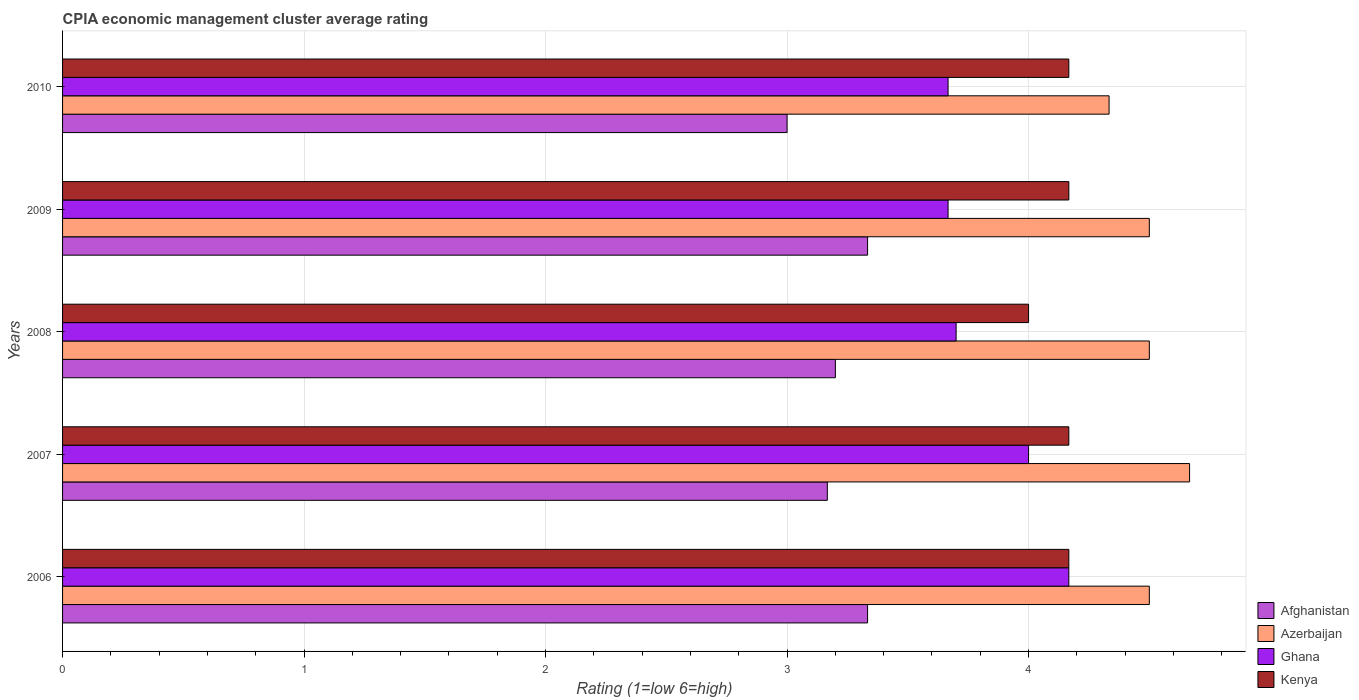Are the number of bars per tick equal to the number of legend labels?
Ensure brevity in your answer.  Yes. What is the label of the 5th group of bars from the top?
Give a very brief answer. 2006. What is the CPIA rating in Ghana in 2006?
Keep it short and to the point. 4.17. Across all years, what is the maximum CPIA rating in Ghana?
Ensure brevity in your answer.  4.17. Across all years, what is the minimum CPIA rating in Ghana?
Make the answer very short. 3.67. What is the total CPIA rating in Kenya in the graph?
Offer a terse response. 20.67. What is the difference between the CPIA rating in Afghanistan in 2008 and that in 2010?
Give a very brief answer. 0.2. What is the difference between the CPIA rating in Kenya in 2006 and the CPIA rating in Afghanistan in 2008?
Offer a terse response. 0.97. What is the average CPIA rating in Kenya per year?
Offer a very short reply. 4.13. In the year 2006, what is the difference between the CPIA rating in Azerbaijan and CPIA rating in Kenya?
Give a very brief answer. 0.33. What is the ratio of the CPIA rating in Kenya in 2006 to that in 2010?
Your answer should be very brief. 1. Is the difference between the CPIA rating in Azerbaijan in 2006 and 2007 greater than the difference between the CPIA rating in Kenya in 2006 and 2007?
Offer a terse response. No. What is the difference between the highest and the second highest CPIA rating in Azerbaijan?
Keep it short and to the point. 0.17. What is the difference between the highest and the lowest CPIA rating in Azerbaijan?
Your answer should be very brief. 0.33. In how many years, is the CPIA rating in Ghana greater than the average CPIA rating in Ghana taken over all years?
Your answer should be very brief. 2. What does the 2nd bar from the bottom in 2006 represents?
Make the answer very short. Azerbaijan. Is it the case that in every year, the sum of the CPIA rating in Ghana and CPIA rating in Afghanistan is greater than the CPIA rating in Azerbaijan?
Offer a terse response. Yes. How many bars are there?
Provide a short and direct response. 20. Where does the legend appear in the graph?
Offer a very short reply. Bottom right. What is the title of the graph?
Ensure brevity in your answer.  CPIA economic management cluster average rating. What is the label or title of the X-axis?
Keep it short and to the point. Rating (1=low 6=high). What is the label or title of the Y-axis?
Make the answer very short. Years. What is the Rating (1=low 6=high) in Afghanistan in 2006?
Offer a very short reply. 3.33. What is the Rating (1=low 6=high) of Azerbaijan in 2006?
Offer a very short reply. 4.5. What is the Rating (1=low 6=high) of Ghana in 2006?
Keep it short and to the point. 4.17. What is the Rating (1=low 6=high) in Kenya in 2006?
Provide a succinct answer. 4.17. What is the Rating (1=low 6=high) in Afghanistan in 2007?
Your answer should be compact. 3.17. What is the Rating (1=low 6=high) of Azerbaijan in 2007?
Provide a succinct answer. 4.67. What is the Rating (1=low 6=high) of Ghana in 2007?
Keep it short and to the point. 4. What is the Rating (1=low 6=high) in Kenya in 2007?
Your answer should be compact. 4.17. What is the Rating (1=low 6=high) of Afghanistan in 2008?
Provide a short and direct response. 3.2. What is the Rating (1=low 6=high) in Azerbaijan in 2008?
Provide a succinct answer. 4.5. What is the Rating (1=low 6=high) of Kenya in 2008?
Ensure brevity in your answer.  4. What is the Rating (1=low 6=high) of Afghanistan in 2009?
Your response must be concise. 3.33. What is the Rating (1=low 6=high) in Ghana in 2009?
Provide a succinct answer. 3.67. What is the Rating (1=low 6=high) of Kenya in 2009?
Provide a succinct answer. 4.17. What is the Rating (1=low 6=high) of Azerbaijan in 2010?
Your response must be concise. 4.33. What is the Rating (1=low 6=high) of Ghana in 2010?
Your answer should be very brief. 3.67. What is the Rating (1=low 6=high) in Kenya in 2010?
Your answer should be compact. 4.17. Across all years, what is the maximum Rating (1=low 6=high) of Afghanistan?
Provide a succinct answer. 3.33. Across all years, what is the maximum Rating (1=low 6=high) of Azerbaijan?
Make the answer very short. 4.67. Across all years, what is the maximum Rating (1=low 6=high) of Ghana?
Make the answer very short. 4.17. Across all years, what is the maximum Rating (1=low 6=high) in Kenya?
Provide a short and direct response. 4.17. Across all years, what is the minimum Rating (1=low 6=high) of Azerbaijan?
Your answer should be very brief. 4.33. Across all years, what is the minimum Rating (1=low 6=high) in Ghana?
Offer a terse response. 3.67. Across all years, what is the minimum Rating (1=low 6=high) in Kenya?
Provide a short and direct response. 4. What is the total Rating (1=low 6=high) of Afghanistan in the graph?
Ensure brevity in your answer.  16.03. What is the total Rating (1=low 6=high) of Azerbaijan in the graph?
Make the answer very short. 22.5. What is the total Rating (1=low 6=high) in Ghana in the graph?
Provide a short and direct response. 19.2. What is the total Rating (1=low 6=high) of Kenya in the graph?
Make the answer very short. 20.67. What is the difference between the Rating (1=low 6=high) of Afghanistan in 2006 and that in 2007?
Provide a succinct answer. 0.17. What is the difference between the Rating (1=low 6=high) of Azerbaijan in 2006 and that in 2007?
Provide a succinct answer. -0.17. What is the difference between the Rating (1=low 6=high) of Kenya in 2006 and that in 2007?
Your response must be concise. 0. What is the difference between the Rating (1=low 6=high) in Afghanistan in 2006 and that in 2008?
Your response must be concise. 0.13. What is the difference between the Rating (1=low 6=high) in Azerbaijan in 2006 and that in 2008?
Give a very brief answer. 0. What is the difference between the Rating (1=low 6=high) in Ghana in 2006 and that in 2008?
Give a very brief answer. 0.47. What is the difference between the Rating (1=low 6=high) in Kenya in 2006 and that in 2008?
Ensure brevity in your answer.  0.17. What is the difference between the Rating (1=low 6=high) in Ghana in 2006 and that in 2009?
Provide a succinct answer. 0.5. What is the difference between the Rating (1=low 6=high) in Kenya in 2006 and that in 2010?
Ensure brevity in your answer.  0. What is the difference between the Rating (1=low 6=high) in Afghanistan in 2007 and that in 2008?
Make the answer very short. -0.03. What is the difference between the Rating (1=low 6=high) of Azerbaijan in 2007 and that in 2008?
Provide a succinct answer. 0.17. What is the difference between the Rating (1=low 6=high) in Ghana in 2007 and that in 2008?
Offer a very short reply. 0.3. What is the difference between the Rating (1=low 6=high) of Kenya in 2007 and that in 2009?
Your response must be concise. 0. What is the difference between the Rating (1=low 6=high) of Afghanistan in 2007 and that in 2010?
Provide a short and direct response. 0.17. What is the difference between the Rating (1=low 6=high) of Kenya in 2007 and that in 2010?
Keep it short and to the point. 0. What is the difference between the Rating (1=low 6=high) in Afghanistan in 2008 and that in 2009?
Your answer should be very brief. -0.13. What is the difference between the Rating (1=low 6=high) in Azerbaijan in 2008 and that in 2009?
Ensure brevity in your answer.  0. What is the difference between the Rating (1=low 6=high) in Kenya in 2008 and that in 2009?
Your answer should be very brief. -0.17. What is the difference between the Rating (1=low 6=high) of Azerbaijan in 2008 and that in 2010?
Offer a terse response. 0.17. What is the difference between the Rating (1=low 6=high) of Kenya in 2008 and that in 2010?
Your response must be concise. -0.17. What is the difference between the Rating (1=low 6=high) in Afghanistan in 2009 and that in 2010?
Offer a terse response. 0.33. What is the difference between the Rating (1=low 6=high) of Azerbaijan in 2009 and that in 2010?
Make the answer very short. 0.17. What is the difference between the Rating (1=low 6=high) of Ghana in 2009 and that in 2010?
Offer a very short reply. 0. What is the difference between the Rating (1=low 6=high) of Afghanistan in 2006 and the Rating (1=low 6=high) of Azerbaijan in 2007?
Make the answer very short. -1.33. What is the difference between the Rating (1=low 6=high) in Afghanistan in 2006 and the Rating (1=low 6=high) in Ghana in 2007?
Ensure brevity in your answer.  -0.67. What is the difference between the Rating (1=low 6=high) of Azerbaijan in 2006 and the Rating (1=low 6=high) of Ghana in 2007?
Provide a short and direct response. 0.5. What is the difference between the Rating (1=low 6=high) in Azerbaijan in 2006 and the Rating (1=low 6=high) in Kenya in 2007?
Give a very brief answer. 0.33. What is the difference between the Rating (1=low 6=high) of Afghanistan in 2006 and the Rating (1=low 6=high) of Azerbaijan in 2008?
Make the answer very short. -1.17. What is the difference between the Rating (1=low 6=high) of Afghanistan in 2006 and the Rating (1=low 6=high) of Ghana in 2008?
Provide a short and direct response. -0.37. What is the difference between the Rating (1=low 6=high) of Afghanistan in 2006 and the Rating (1=low 6=high) of Kenya in 2008?
Your answer should be compact. -0.67. What is the difference between the Rating (1=low 6=high) in Ghana in 2006 and the Rating (1=low 6=high) in Kenya in 2008?
Provide a succinct answer. 0.17. What is the difference between the Rating (1=low 6=high) in Afghanistan in 2006 and the Rating (1=low 6=high) in Azerbaijan in 2009?
Give a very brief answer. -1.17. What is the difference between the Rating (1=low 6=high) of Afghanistan in 2006 and the Rating (1=low 6=high) of Kenya in 2009?
Ensure brevity in your answer.  -0.83. What is the difference between the Rating (1=low 6=high) in Azerbaijan in 2006 and the Rating (1=low 6=high) in Ghana in 2009?
Your answer should be compact. 0.83. What is the difference between the Rating (1=low 6=high) of Azerbaijan in 2006 and the Rating (1=low 6=high) of Kenya in 2009?
Give a very brief answer. 0.33. What is the difference between the Rating (1=low 6=high) in Ghana in 2006 and the Rating (1=low 6=high) in Kenya in 2009?
Your answer should be very brief. 0. What is the difference between the Rating (1=low 6=high) in Afghanistan in 2006 and the Rating (1=low 6=high) in Ghana in 2010?
Your answer should be very brief. -0.33. What is the difference between the Rating (1=low 6=high) in Afghanistan in 2006 and the Rating (1=low 6=high) in Kenya in 2010?
Your answer should be compact. -0.83. What is the difference between the Rating (1=low 6=high) of Azerbaijan in 2006 and the Rating (1=low 6=high) of Ghana in 2010?
Provide a short and direct response. 0.83. What is the difference between the Rating (1=low 6=high) in Azerbaijan in 2006 and the Rating (1=low 6=high) in Kenya in 2010?
Ensure brevity in your answer.  0.33. What is the difference between the Rating (1=low 6=high) of Ghana in 2006 and the Rating (1=low 6=high) of Kenya in 2010?
Provide a succinct answer. 0. What is the difference between the Rating (1=low 6=high) of Afghanistan in 2007 and the Rating (1=low 6=high) of Azerbaijan in 2008?
Offer a terse response. -1.33. What is the difference between the Rating (1=low 6=high) of Afghanistan in 2007 and the Rating (1=low 6=high) of Ghana in 2008?
Offer a terse response. -0.53. What is the difference between the Rating (1=low 6=high) in Afghanistan in 2007 and the Rating (1=low 6=high) in Kenya in 2008?
Provide a succinct answer. -0.83. What is the difference between the Rating (1=low 6=high) of Azerbaijan in 2007 and the Rating (1=low 6=high) of Ghana in 2008?
Make the answer very short. 0.97. What is the difference between the Rating (1=low 6=high) in Afghanistan in 2007 and the Rating (1=low 6=high) in Azerbaijan in 2009?
Ensure brevity in your answer.  -1.33. What is the difference between the Rating (1=low 6=high) of Afghanistan in 2007 and the Rating (1=low 6=high) of Ghana in 2009?
Ensure brevity in your answer.  -0.5. What is the difference between the Rating (1=low 6=high) in Afghanistan in 2007 and the Rating (1=low 6=high) in Kenya in 2009?
Keep it short and to the point. -1. What is the difference between the Rating (1=low 6=high) of Azerbaijan in 2007 and the Rating (1=low 6=high) of Ghana in 2009?
Your answer should be very brief. 1. What is the difference between the Rating (1=low 6=high) in Azerbaijan in 2007 and the Rating (1=low 6=high) in Kenya in 2009?
Offer a very short reply. 0.5. What is the difference between the Rating (1=low 6=high) of Ghana in 2007 and the Rating (1=low 6=high) of Kenya in 2009?
Provide a succinct answer. -0.17. What is the difference between the Rating (1=low 6=high) in Afghanistan in 2007 and the Rating (1=low 6=high) in Azerbaijan in 2010?
Offer a terse response. -1.17. What is the difference between the Rating (1=low 6=high) of Afghanistan in 2007 and the Rating (1=low 6=high) of Ghana in 2010?
Your answer should be compact. -0.5. What is the difference between the Rating (1=low 6=high) of Ghana in 2007 and the Rating (1=low 6=high) of Kenya in 2010?
Provide a succinct answer. -0.17. What is the difference between the Rating (1=low 6=high) of Afghanistan in 2008 and the Rating (1=low 6=high) of Azerbaijan in 2009?
Keep it short and to the point. -1.3. What is the difference between the Rating (1=low 6=high) of Afghanistan in 2008 and the Rating (1=low 6=high) of Ghana in 2009?
Ensure brevity in your answer.  -0.47. What is the difference between the Rating (1=low 6=high) of Afghanistan in 2008 and the Rating (1=low 6=high) of Kenya in 2009?
Offer a terse response. -0.97. What is the difference between the Rating (1=low 6=high) in Azerbaijan in 2008 and the Rating (1=low 6=high) in Ghana in 2009?
Make the answer very short. 0.83. What is the difference between the Rating (1=low 6=high) in Azerbaijan in 2008 and the Rating (1=low 6=high) in Kenya in 2009?
Ensure brevity in your answer.  0.33. What is the difference between the Rating (1=low 6=high) of Ghana in 2008 and the Rating (1=low 6=high) of Kenya in 2009?
Give a very brief answer. -0.47. What is the difference between the Rating (1=low 6=high) in Afghanistan in 2008 and the Rating (1=low 6=high) in Azerbaijan in 2010?
Offer a very short reply. -1.13. What is the difference between the Rating (1=low 6=high) in Afghanistan in 2008 and the Rating (1=low 6=high) in Ghana in 2010?
Offer a terse response. -0.47. What is the difference between the Rating (1=low 6=high) of Afghanistan in 2008 and the Rating (1=low 6=high) of Kenya in 2010?
Provide a short and direct response. -0.97. What is the difference between the Rating (1=low 6=high) of Ghana in 2008 and the Rating (1=low 6=high) of Kenya in 2010?
Offer a very short reply. -0.47. What is the difference between the Rating (1=low 6=high) of Afghanistan in 2009 and the Rating (1=low 6=high) of Ghana in 2010?
Offer a terse response. -0.33. What is the difference between the Rating (1=low 6=high) of Azerbaijan in 2009 and the Rating (1=low 6=high) of Kenya in 2010?
Provide a short and direct response. 0.33. What is the average Rating (1=low 6=high) of Afghanistan per year?
Make the answer very short. 3.21. What is the average Rating (1=low 6=high) of Ghana per year?
Provide a short and direct response. 3.84. What is the average Rating (1=low 6=high) in Kenya per year?
Your answer should be compact. 4.13. In the year 2006, what is the difference between the Rating (1=low 6=high) of Afghanistan and Rating (1=low 6=high) of Azerbaijan?
Provide a succinct answer. -1.17. In the year 2006, what is the difference between the Rating (1=low 6=high) of Afghanistan and Rating (1=low 6=high) of Kenya?
Your answer should be compact. -0.83. In the year 2006, what is the difference between the Rating (1=low 6=high) of Azerbaijan and Rating (1=low 6=high) of Ghana?
Your answer should be very brief. 0.33. In the year 2006, what is the difference between the Rating (1=low 6=high) in Ghana and Rating (1=low 6=high) in Kenya?
Make the answer very short. 0. In the year 2007, what is the difference between the Rating (1=low 6=high) in Azerbaijan and Rating (1=low 6=high) in Ghana?
Make the answer very short. 0.67. In the year 2008, what is the difference between the Rating (1=low 6=high) of Afghanistan and Rating (1=low 6=high) of Azerbaijan?
Give a very brief answer. -1.3. In the year 2008, what is the difference between the Rating (1=low 6=high) in Afghanistan and Rating (1=low 6=high) in Ghana?
Your answer should be compact. -0.5. In the year 2008, what is the difference between the Rating (1=low 6=high) of Afghanistan and Rating (1=low 6=high) of Kenya?
Ensure brevity in your answer.  -0.8. In the year 2009, what is the difference between the Rating (1=low 6=high) in Afghanistan and Rating (1=low 6=high) in Azerbaijan?
Make the answer very short. -1.17. In the year 2009, what is the difference between the Rating (1=low 6=high) in Afghanistan and Rating (1=low 6=high) in Kenya?
Provide a succinct answer. -0.83. In the year 2009, what is the difference between the Rating (1=low 6=high) in Azerbaijan and Rating (1=low 6=high) in Ghana?
Offer a terse response. 0.83. In the year 2010, what is the difference between the Rating (1=low 6=high) in Afghanistan and Rating (1=low 6=high) in Azerbaijan?
Keep it short and to the point. -1.33. In the year 2010, what is the difference between the Rating (1=low 6=high) of Afghanistan and Rating (1=low 6=high) of Ghana?
Your answer should be very brief. -0.67. In the year 2010, what is the difference between the Rating (1=low 6=high) of Afghanistan and Rating (1=low 6=high) of Kenya?
Provide a short and direct response. -1.17. In the year 2010, what is the difference between the Rating (1=low 6=high) in Azerbaijan and Rating (1=low 6=high) in Ghana?
Give a very brief answer. 0.67. In the year 2010, what is the difference between the Rating (1=low 6=high) of Azerbaijan and Rating (1=low 6=high) of Kenya?
Your answer should be compact. 0.17. In the year 2010, what is the difference between the Rating (1=low 6=high) in Ghana and Rating (1=low 6=high) in Kenya?
Offer a very short reply. -0.5. What is the ratio of the Rating (1=low 6=high) of Afghanistan in 2006 to that in 2007?
Make the answer very short. 1.05. What is the ratio of the Rating (1=low 6=high) of Ghana in 2006 to that in 2007?
Keep it short and to the point. 1.04. What is the ratio of the Rating (1=low 6=high) of Kenya in 2006 to that in 2007?
Your answer should be compact. 1. What is the ratio of the Rating (1=low 6=high) in Afghanistan in 2006 to that in 2008?
Keep it short and to the point. 1.04. What is the ratio of the Rating (1=low 6=high) in Ghana in 2006 to that in 2008?
Provide a short and direct response. 1.13. What is the ratio of the Rating (1=low 6=high) of Kenya in 2006 to that in 2008?
Provide a succinct answer. 1.04. What is the ratio of the Rating (1=low 6=high) of Azerbaijan in 2006 to that in 2009?
Keep it short and to the point. 1. What is the ratio of the Rating (1=low 6=high) of Ghana in 2006 to that in 2009?
Provide a succinct answer. 1.14. What is the ratio of the Rating (1=low 6=high) in Kenya in 2006 to that in 2009?
Ensure brevity in your answer.  1. What is the ratio of the Rating (1=low 6=high) in Ghana in 2006 to that in 2010?
Your answer should be compact. 1.14. What is the ratio of the Rating (1=low 6=high) in Kenya in 2006 to that in 2010?
Offer a terse response. 1. What is the ratio of the Rating (1=low 6=high) of Afghanistan in 2007 to that in 2008?
Make the answer very short. 0.99. What is the ratio of the Rating (1=low 6=high) of Azerbaijan in 2007 to that in 2008?
Offer a terse response. 1.04. What is the ratio of the Rating (1=low 6=high) in Ghana in 2007 to that in 2008?
Make the answer very short. 1.08. What is the ratio of the Rating (1=low 6=high) of Kenya in 2007 to that in 2008?
Keep it short and to the point. 1.04. What is the ratio of the Rating (1=low 6=high) of Afghanistan in 2007 to that in 2009?
Your answer should be very brief. 0.95. What is the ratio of the Rating (1=low 6=high) of Afghanistan in 2007 to that in 2010?
Offer a very short reply. 1.06. What is the ratio of the Rating (1=low 6=high) of Azerbaijan in 2007 to that in 2010?
Offer a very short reply. 1.08. What is the ratio of the Rating (1=low 6=high) in Kenya in 2007 to that in 2010?
Ensure brevity in your answer.  1. What is the ratio of the Rating (1=low 6=high) in Afghanistan in 2008 to that in 2009?
Ensure brevity in your answer.  0.96. What is the ratio of the Rating (1=low 6=high) of Azerbaijan in 2008 to that in 2009?
Keep it short and to the point. 1. What is the ratio of the Rating (1=low 6=high) of Ghana in 2008 to that in 2009?
Make the answer very short. 1.01. What is the ratio of the Rating (1=low 6=high) in Afghanistan in 2008 to that in 2010?
Make the answer very short. 1.07. What is the ratio of the Rating (1=low 6=high) of Azerbaijan in 2008 to that in 2010?
Your answer should be very brief. 1.04. What is the ratio of the Rating (1=low 6=high) of Ghana in 2008 to that in 2010?
Give a very brief answer. 1.01. What is the ratio of the Rating (1=low 6=high) of Azerbaijan in 2009 to that in 2010?
Your answer should be compact. 1.04. What is the difference between the highest and the second highest Rating (1=low 6=high) of Afghanistan?
Your answer should be very brief. 0. What is the difference between the highest and the lowest Rating (1=low 6=high) of Azerbaijan?
Your response must be concise. 0.33. 